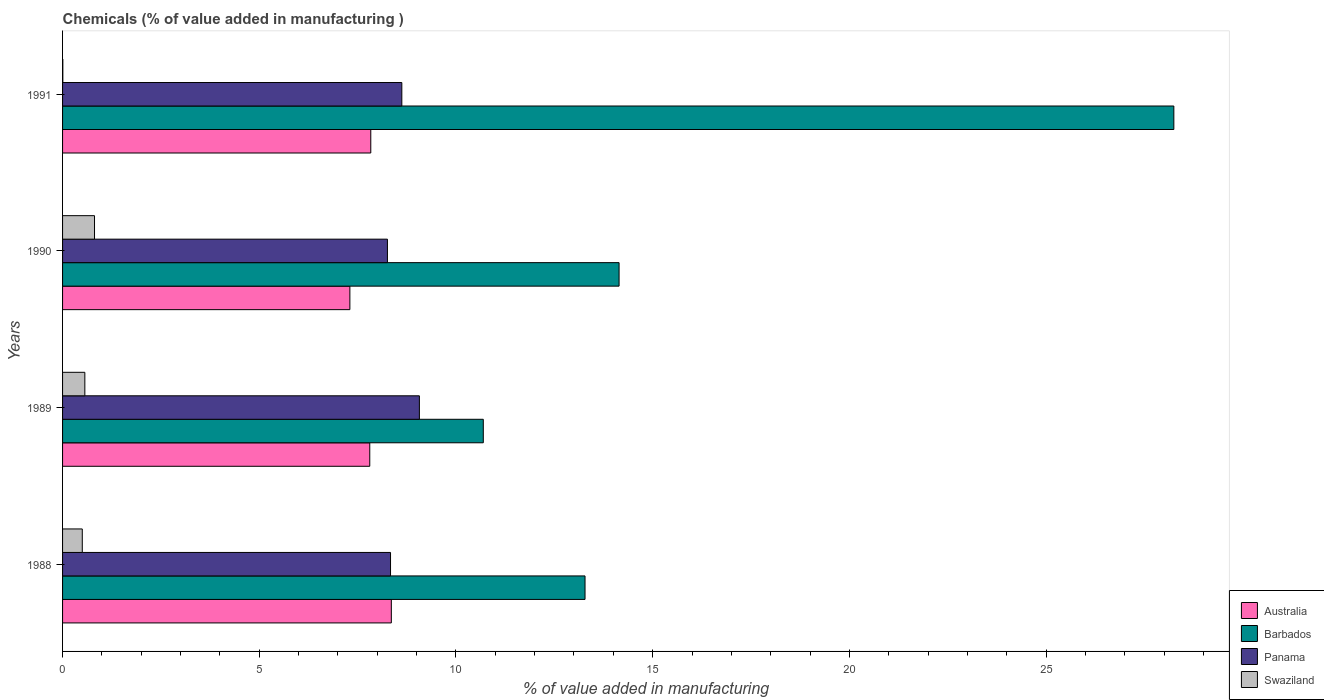How many different coloured bars are there?
Make the answer very short. 4. Are the number of bars on each tick of the Y-axis equal?
Offer a terse response. Yes. How many bars are there on the 3rd tick from the bottom?
Make the answer very short. 4. What is the label of the 4th group of bars from the top?
Provide a short and direct response. 1988. What is the value added in manufacturing chemicals in Australia in 1990?
Keep it short and to the point. 7.3. Across all years, what is the maximum value added in manufacturing chemicals in Australia?
Offer a very short reply. 8.36. Across all years, what is the minimum value added in manufacturing chemicals in Panama?
Your answer should be compact. 8.26. In which year was the value added in manufacturing chemicals in Swaziland maximum?
Ensure brevity in your answer.  1990. In which year was the value added in manufacturing chemicals in Australia minimum?
Your answer should be compact. 1990. What is the total value added in manufacturing chemicals in Australia in the graph?
Ensure brevity in your answer.  31.3. What is the difference between the value added in manufacturing chemicals in Swaziland in 1989 and that in 1991?
Make the answer very short. 0.56. What is the difference between the value added in manufacturing chemicals in Swaziland in 1990 and the value added in manufacturing chemicals in Barbados in 1989?
Your answer should be compact. -9.88. What is the average value added in manufacturing chemicals in Australia per year?
Give a very brief answer. 7.83. In the year 1988, what is the difference between the value added in manufacturing chemicals in Barbados and value added in manufacturing chemicals in Swaziland?
Offer a terse response. 12.78. What is the ratio of the value added in manufacturing chemicals in Panama in 1988 to that in 1991?
Make the answer very short. 0.97. Is the value added in manufacturing chemicals in Panama in 1990 less than that in 1991?
Give a very brief answer. Yes. What is the difference between the highest and the second highest value added in manufacturing chemicals in Barbados?
Your answer should be very brief. 14.1. What is the difference between the highest and the lowest value added in manufacturing chemicals in Panama?
Your answer should be very brief. 0.81. Is the sum of the value added in manufacturing chemicals in Barbados in 1989 and 1991 greater than the maximum value added in manufacturing chemicals in Australia across all years?
Your response must be concise. Yes. What does the 1st bar from the top in 1988 represents?
Provide a short and direct response. Swaziland. What does the 1st bar from the bottom in 1989 represents?
Offer a very short reply. Australia. Is it the case that in every year, the sum of the value added in manufacturing chemicals in Barbados and value added in manufacturing chemicals in Panama is greater than the value added in manufacturing chemicals in Australia?
Make the answer very short. Yes. How many bars are there?
Make the answer very short. 16. Are all the bars in the graph horizontal?
Offer a very short reply. Yes. How many years are there in the graph?
Provide a succinct answer. 4. What is the difference between two consecutive major ticks on the X-axis?
Ensure brevity in your answer.  5. Are the values on the major ticks of X-axis written in scientific E-notation?
Ensure brevity in your answer.  No. Does the graph contain any zero values?
Make the answer very short. No. Does the graph contain grids?
Provide a succinct answer. No. What is the title of the graph?
Your answer should be compact. Chemicals (% of value added in manufacturing ). What is the label or title of the X-axis?
Your answer should be very brief. % of value added in manufacturing. What is the % of value added in manufacturing of Australia in 1988?
Make the answer very short. 8.36. What is the % of value added in manufacturing of Barbados in 1988?
Offer a terse response. 13.28. What is the % of value added in manufacturing in Panama in 1988?
Provide a short and direct response. 8.34. What is the % of value added in manufacturing in Swaziland in 1988?
Your answer should be compact. 0.5. What is the % of value added in manufacturing in Australia in 1989?
Provide a succinct answer. 7.81. What is the % of value added in manufacturing in Barbados in 1989?
Offer a terse response. 10.69. What is the % of value added in manufacturing in Panama in 1989?
Offer a terse response. 9.07. What is the % of value added in manufacturing in Swaziland in 1989?
Give a very brief answer. 0.57. What is the % of value added in manufacturing of Australia in 1990?
Provide a short and direct response. 7.3. What is the % of value added in manufacturing of Barbados in 1990?
Offer a very short reply. 14.15. What is the % of value added in manufacturing in Panama in 1990?
Your response must be concise. 8.26. What is the % of value added in manufacturing in Swaziland in 1990?
Your response must be concise. 0.81. What is the % of value added in manufacturing of Australia in 1991?
Provide a succinct answer. 7.83. What is the % of value added in manufacturing of Barbados in 1991?
Offer a terse response. 28.25. What is the % of value added in manufacturing of Panama in 1991?
Provide a succinct answer. 8.62. What is the % of value added in manufacturing of Swaziland in 1991?
Ensure brevity in your answer.  0.01. Across all years, what is the maximum % of value added in manufacturing of Australia?
Provide a short and direct response. 8.36. Across all years, what is the maximum % of value added in manufacturing of Barbados?
Your answer should be very brief. 28.25. Across all years, what is the maximum % of value added in manufacturing of Panama?
Give a very brief answer. 9.07. Across all years, what is the maximum % of value added in manufacturing in Swaziland?
Your response must be concise. 0.81. Across all years, what is the minimum % of value added in manufacturing of Australia?
Your response must be concise. 7.3. Across all years, what is the minimum % of value added in manufacturing in Barbados?
Provide a short and direct response. 10.69. Across all years, what is the minimum % of value added in manufacturing of Panama?
Give a very brief answer. 8.26. Across all years, what is the minimum % of value added in manufacturing in Swaziland?
Your answer should be very brief. 0.01. What is the total % of value added in manufacturing of Australia in the graph?
Your answer should be very brief. 31.3. What is the total % of value added in manufacturing in Barbados in the graph?
Provide a short and direct response. 66.37. What is the total % of value added in manufacturing of Panama in the graph?
Give a very brief answer. 34.29. What is the total % of value added in manufacturing of Swaziland in the graph?
Provide a short and direct response. 1.89. What is the difference between the % of value added in manufacturing in Australia in 1988 and that in 1989?
Your answer should be compact. 0.55. What is the difference between the % of value added in manufacturing in Barbados in 1988 and that in 1989?
Your answer should be very brief. 2.59. What is the difference between the % of value added in manufacturing of Panama in 1988 and that in 1989?
Give a very brief answer. -0.73. What is the difference between the % of value added in manufacturing in Swaziland in 1988 and that in 1989?
Give a very brief answer. -0.07. What is the difference between the % of value added in manufacturing in Australia in 1988 and that in 1990?
Give a very brief answer. 1.05. What is the difference between the % of value added in manufacturing in Barbados in 1988 and that in 1990?
Your answer should be compact. -0.87. What is the difference between the % of value added in manufacturing of Panama in 1988 and that in 1990?
Ensure brevity in your answer.  0.08. What is the difference between the % of value added in manufacturing of Swaziland in 1988 and that in 1990?
Your response must be concise. -0.31. What is the difference between the % of value added in manufacturing in Australia in 1988 and that in 1991?
Offer a very short reply. 0.52. What is the difference between the % of value added in manufacturing of Barbados in 1988 and that in 1991?
Keep it short and to the point. -14.97. What is the difference between the % of value added in manufacturing of Panama in 1988 and that in 1991?
Provide a succinct answer. -0.29. What is the difference between the % of value added in manufacturing of Swaziland in 1988 and that in 1991?
Make the answer very short. 0.49. What is the difference between the % of value added in manufacturing in Australia in 1989 and that in 1990?
Offer a terse response. 0.51. What is the difference between the % of value added in manufacturing in Barbados in 1989 and that in 1990?
Offer a terse response. -3.45. What is the difference between the % of value added in manufacturing in Panama in 1989 and that in 1990?
Offer a terse response. 0.81. What is the difference between the % of value added in manufacturing of Swaziland in 1989 and that in 1990?
Provide a succinct answer. -0.25. What is the difference between the % of value added in manufacturing in Australia in 1989 and that in 1991?
Provide a succinct answer. -0.03. What is the difference between the % of value added in manufacturing in Barbados in 1989 and that in 1991?
Your response must be concise. -17.55. What is the difference between the % of value added in manufacturing in Panama in 1989 and that in 1991?
Provide a succinct answer. 0.45. What is the difference between the % of value added in manufacturing of Swaziland in 1989 and that in 1991?
Your answer should be compact. 0.56. What is the difference between the % of value added in manufacturing in Australia in 1990 and that in 1991?
Your response must be concise. -0.53. What is the difference between the % of value added in manufacturing of Barbados in 1990 and that in 1991?
Your response must be concise. -14.1. What is the difference between the % of value added in manufacturing of Panama in 1990 and that in 1991?
Your response must be concise. -0.37. What is the difference between the % of value added in manufacturing of Swaziland in 1990 and that in 1991?
Offer a very short reply. 0.81. What is the difference between the % of value added in manufacturing in Australia in 1988 and the % of value added in manufacturing in Barbados in 1989?
Your answer should be very brief. -2.34. What is the difference between the % of value added in manufacturing of Australia in 1988 and the % of value added in manufacturing of Panama in 1989?
Keep it short and to the point. -0.71. What is the difference between the % of value added in manufacturing in Australia in 1988 and the % of value added in manufacturing in Swaziland in 1989?
Ensure brevity in your answer.  7.79. What is the difference between the % of value added in manufacturing in Barbados in 1988 and the % of value added in manufacturing in Panama in 1989?
Give a very brief answer. 4.21. What is the difference between the % of value added in manufacturing of Barbados in 1988 and the % of value added in manufacturing of Swaziland in 1989?
Make the answer very short. 12.71. What is the difference between the % of value added in manufacturing in Panama in 1988 and the % of value added in manufacturing in Swaziland in 1989?
Offer a terse response. 7.77. What is the difference between the % of value added in manufacturing of Australia in 1988 and the % of value added in manufacturing of Barbados in 1990?
Provide a short and direct response. -5.79. What is the difference between the % of value added in manufacturing of Australia in 1988 and the % of value added in manufacturing of Panama in 1990?
Make the answer very short. 0.1. What is the difference between the % of value added in manufacturing of Australia in 1988 and the % of value added in manufacturing of Swaziland in 1990?
Offer a very short reply. 7.54. What is the difference between the % of value added in manufacturing in Barbados in 1988 and the % of value added in manufacturing in Panama in 1990?
Ensure brevity in your answer.  5.02. What is the difference between the % of value added in manufacturing of Barbados in 1988 and the % of value added in manufacturing of Swaziland in 1990?
Make the answer very short. 12.47. What is the difference between the % of value added in manufacturing in Panama in 1988 and the % of value added in manufacturing in Swaziland in 1990?
Offer a very short reply. 7.52. What is the difference between the % of value added in manufacturing in Australia in 1988 and the % of value added in manufacturing in Barbados in 1991?
Provide a short and direct response. -19.89. What is the difference between the % of value added in manufacturing of Australia in 1988 and the % of value added in manufacturing of Panama in 1991?
Keep it short and to the point. -0.27. What is the difference between the % of value added in manufacturing in Australia in 1988 and the % of value added in manufacturing in Swaziland in 1991?
Ensure brevity in your answer.  8.35. What is the difference between the % of value added in manufacturing of Barbados in 1988 and the % of value added in manufacturing of Panama in 1991?
Make the answer very short. 4.66. What is the difference between the % of value added in manufacturing in Barbados in 1988 and the % of value added in manufacturing in Swaziland in 1991?
Give a very brief answer. 13.27. What is the difference between the % of value added in manufacturing in Panama in 1988 and the % of value added in manufacturing in Swaziland in 1991?
Provide a succinct answer. 8.33. What is the difference between the % of value added in manufacturing of Australia in 1989 and the % of value added in manufacturing of Barbados in 1990?
Ensure brevity in your answer.  -6.34. What is the difference between the % of value added in manufacturing of Australia in 1989 and the % of value added in manufacturing of Panama in 1990?
Your answer should be very brief. -0.45. What is the difference between the % of value added in manufacturing of Australia in 1989 and the % of value added in manufacturing of Swaziland in 1990?
Keep it short and to the point. 7. What is the difference between the % of value added in manufacturing of Barbados in 1989 and the % of value added in manufacturing of Panama in 1990?
Ensure brevity in your answer.  2.44. What is the difference between the % of value added in manufacturing of Barbados in 1989 and the % of value added in manufacturing of Swaziland in 1990?
Your answer should be very brief. 9.88. What is the difference between the % of value added in manufacturing in Panama in 1989 and the % of value added in manufacturing in Swaziland in 1990?
Offer a very short reply. 8.26. What is the difference between the % of value added in manufacturing of Australia in 1989 and the % of value added in manufacturing of Barbados in 1991?
Ensure brevity in your answer.  -20.44. What is the difference between the % of value added in manufacturing of Australia in 1989 and the % of value added in manufacturing of Panama in 1991?
Offer a very short reply. -0.81. What is the difference between the % of value added in manufacturing in Australia in 1989 and the % of value added in manufacturing in Swaziland in 1991?
Your response must be concise. 7.8. What is the difference between the % of value added in manufacturing in Barbados in 1989 and the % of value added in manufacturing in Panama in 1991?
Give a very brief answer. 2.07. What is the difference between the % of value added in manufacturing in Barbados in 1989 and the % of value added in manufacturing in Swaziland in 1991?
Your answer should be compact. 10.69. What is the difference between the % of value added in manufacturing of Panama in 1989 and the % of value added in manufacturing of Swaziland in 1991?
Keep it short and to the point. 9.06. What is the difference between the % of value added in manufacturing in Australia in 1990 and the % of value added in manufacturing in Barbados in 1991?
Keep it short and to the point. -20.94. What is the difference between the % of value added in manufacturing of Australia in 1990 and the % of value added in manufacturing of Panama in 1991?
Offer a terse response. -1.32. What is the difference between the % of value added in manufacturing in Australia in 1990 and the % of value added in manufacturing in Swaziland in 1991?
Your answer should be very brief. 7.3. What is the difference between the % of value added in manufacturing in Barbados in 1990 and the % of value added in manufacturing in Panama in 1991?
Offer a very short reply. 5.52. What is the difference between the % of value added in manufacturing of Barbados in 1990 and the % of value added in manufacturing of Swaziland in 1991?
Offer a very short reply. 14.14. What is the difference between the % of value added in manufacturing in Panama in 1990 and the % of value added in manufacturing in Swaziland in 1991?
Keep it short and to the point. 8.25. What is the average % of value added in manufacturing in Australia per year?
Your answer should be very brief. 7.83. What is the average % of value added in manufacturing of Barbados per year?
Your answer should be very brief. 16.59. What is the average % of value added in manufacturing of Panama per year?
Offer a very short reply. 8.57. What is the average % of value added in manufacturing of Swaziland per year?
Make the answer very short. 0.47. In the year 1988, what is the difference between the % of value added in manufacturing of Australia and % of value added in manufacturing of Barbados?
Your response must be concise. -4.92. In the year 1988, what is the difference between the % of value added in manufacturing in Australia and % of value added in manufacturing in Panama?
Provide a succinct answer. 0.02. In the year 1988, what is the difference between the % of value added in manufacturing of Australia and % of value added in manufacturing of Swaziland?
Your answer should be very brief. 7.86. In the year 1988, what is the difference between the % of value added in manufacturing of Barbados and % of value added in manufacturing of Panama?
Provide a short and direct response. 4.94. In the year 1988, what is the difference between the % of value added in manufacturing of Barbados and % of value added in manufacturing of Swaziland?
Make the answer very short. 12.78. In the year 1988, what is the difference between the % of value added in manufacturing in Panama and % of value added in manufacturing in Swaziland?
Ensure brevity in your answer.  7.84. In the year 1989, what is the difference between the % of value added in manufacturing in Australia and % of value added in manufacturing in Barbados?
Your response must be concise. -2.89. In the year 1989, what is the difference between the % of value added in manufacturing of Australia and % of value added in manufacturing of Panama?
Provide a short and direct response. -1.26. In the year 1989, what is the difference between the % of value added in manufacturing of Australia and % of value added in manufacturing of Swaziland?
Your answer should be compact. 7.24. In the year 1989, what is the difference between the % of value added in manufacturing in Barbados and % of value added in manufacturing in Panama?
Offer a terse response. 1.62. In the year 1989, what is the difference between the % of value added in manufacturing in Barbados and % of value added in manufacturing in Swaziland?
Provide a succinct answer. 10.13. In the year 1989, what is the difference between the % of value added in manufacturing in Panama and % of value added in manufacturing in Swaziland?
Make the answer very short. 8.5. In the year 1990, what is the difference between the % of value added in manufacturing of Australia and % of value added in manufacturing of Barbados?
Provide a succinct answer. -6.84. In the year 1990, what is the difference between the % of value added in manufacturing in Australia and % of value added in manufacturing in Panama?
Make the answer very short. -0.95. In the year 1990, what is the difference between the % of value added in manufacturing in Australia and % of value added in manufacturing in Swaziland?
Keep it short and to the point. 6.49. In the year 1990, what is the difference between the % of value added in manufacturing of Barbados and % of value added in manufacturing of Panama?
Provide a short and direct response. 5.89. In the year 1990, what is the difference between the % of value added in manufacturing of Barbados and % of value added in manufacturing of Swaziland?
Keep it short and to the point. 13.33. In the year 1990, what is the difference between the % of value added in manufacturing of Panama and % of value added in manufacturing of Swaziland?
Give a very brief answer. 7.45. In the year 1991, what is the difference between the % of value added in manufacturing in Australia and % of value added in manufacturing in Barbados?
Make the answer very short. -20.41. In the year 1991, what is the difference between the % of value added in manufacturing in Australia and % of value added in manufacturing in Panama?
Provide a short and direct response. -0.79. In the year 1991, what is the difference between the % of value added in manufacturing of Australia and % of value added in manufacturing of Swaziland?
Offer a terse response. 7.83. In the year 1991, what is the difference between the % of value added in manufacturing in Barbados and % of value added in manufacturing in Panama?
Give a very brief answer. 19.62. In the year 1991, what is the difference between the % of value added in manufacturing of Barbados and % of value added in manufacturing of Swaziland?
Your answer should be very brief. 28.24. In the year 1991, what is the difference between the % of value added in manufacturing of Panama and % of value added in manufacturing of Swaziland?
Make the answer very short. 8.62. What is the ratio of the % of value added in manufacturing in Australia in 1988 to that in 1989?
Offer a terse response. 1.07. What is the ratio of the % of value added in manufacturing in Barbados in 1988 to that in 1989?
Offer a terse response. 1.24. What is the ratio of the % of value added in manufacturing in Panama in 1988 to that in 1989?
Offer a terse response. 0.92. What is the ratio of the % of value added in manufacturing of Swaziland in 1988 to that in 1989?
Ensure brevity in your answer.  0.89. What is the ratio of the % of value added in manufacturing of Australia in 1988 to that in 1990?
Give a very brief answer. 1.14. What is the ratio of the % of value added in manufacturing of Barbados in 1988 to that in 1990?
Provide a succinct answer. 0.94. What is the ratio of the % of value added in manufacturing of Panama in 1988 to that in 1990?
Provide a succinct answer. 1.01. What is the ratio of the % of value added in manufacturing in Swaziland in 1988 to that in 1990?
Ensure brevity in your answer.  0.62. What is the ratio of the % of value added in manufacturing of Australia in 1988 to that in 1991?
Provide a succinct answer. 1.07. What is the ratio of the % of value added in manufacturing of Barbados in 1988 to that in 1991?
Provide a short and direct response. 0.47. What is the ratio of the % of value added in manufacturing in Panama in 1988 to that in 1991?
Make the answer very short. 0.97. What is the ratio of the % of value added in manufacturing in Swaziland in 1988 to that in 1991?
Offer a terse response. 76.96. What is the ratio of the % of value added in manufacturing in Australia in 1989 to that in 1990?
Your response must be concise. 1.07. What is the ratio of the % of value added in manufacturing in Barbados in 1989 to that in 1990?
Offer a terse response. 0.76. What is the ratio of the % of value added in manufacturing in Panama in 1989 to that in 1990?
Ensure brevity in your answer.  1.1. What is the ratio of the % of value added in manufacturing of Swaziland in 1989 to that in 1990?
Your answer should be very brief. 0.7. What is the ratio of the % of value added in manufacturing in Australia in 1989 to that in 1991?
Provide a short and direct response. 1. What is the ratio of the % of value added in manufacturing of Barbados in 1989 to that in 1991?
Offer a terse response. 0.38. What is the ratio of the % of value added in manufacturing in Panama in 1989 to that in 1991?
Your response must be concise. 1.05. What is the ratio of the % of value added in manufacturing of Swaziland in 1989 to that in 1991?
Ensure brevity in your answer.  86.96. What is the ratio of the % of value added in manufacturing of Australia in 1990 to that in 1991?
Provide a short and direct response. 0.93. What is the ratio of the % of value added in manufacturing in Barbados in 1990 to that in 1991?
Offer a very short reply. 0.5. What is the ratio of the % of value added in manufacturing of Panama in 1990 to that in 1991?
Keep it short and to the point. 0.96. What is the ratio of the % of value added in manufacturing of Swaziland in 1990 to that in 1991?
Your answer should be compact. 124.7. What is the difference between the highest and the second highest % of value added in manufacturing of Australia?
Your response must be concise. 0.52. What is the difference between the highest and the second highest % of value added in manufacturing of Barbados?
Your answer should be very brief. 14.1. What is the difference between the highest and the second highest % of value added in manufacturing of Panama?
Keep it short and to the point. 0.45. What is the difference between the highest and the second highest % of value added in manufacturing of Swaziland?
Give a very brief answer. 0.25. What is the difference between the highest and the lowest % of value added in manufacturing of Australia?
Provide a short and direct response. 1.05. What is the difference between the highest and the lowest % of value added in manufacturing of Barbados?
Keep it short and to the point. 17.55. What is the difference between the highest and the lowest % of value added in manufacturing of Panama?
Give a very brief answer. 0.81. What is the difference between the highest and the lowest % of value added in manufacturing of Swaziland?
Provide a succinct answer. 0.81. 